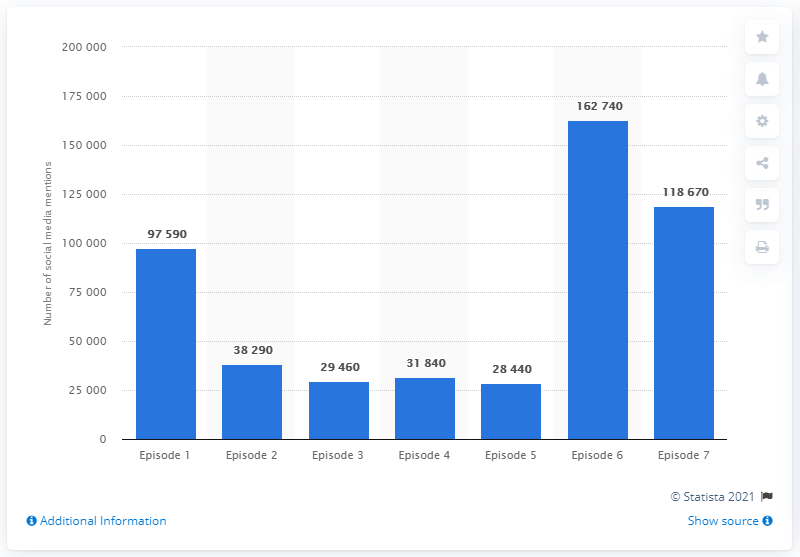Give some essential details in this illustration. The number of times the season opener was mentioned on social media was 97,590. 